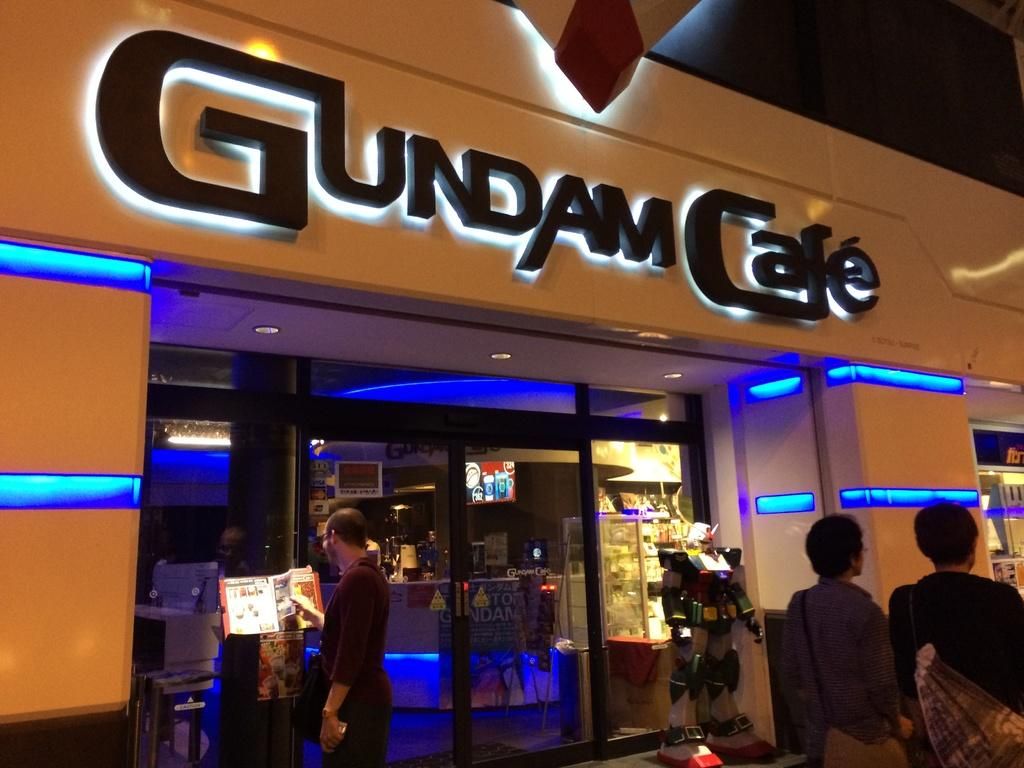What type of establishment is depicted in the image? There is a store in the image. What can be seen inside the store? There are objects inside the store. What is unique about the store's walls? The store has glass walls. What can be seen in the image that provides illumination? There are lights visible in the image. How many people are present in the image? There are people in the image, including one person holding something. What is the nature of the robot in the image? There is a robot in the image. How many chickens are visible in the image? There are no chickens present in the image. What type of badge is the person holding in the image? The person in the image is not holding a badge; they are holding something else. 